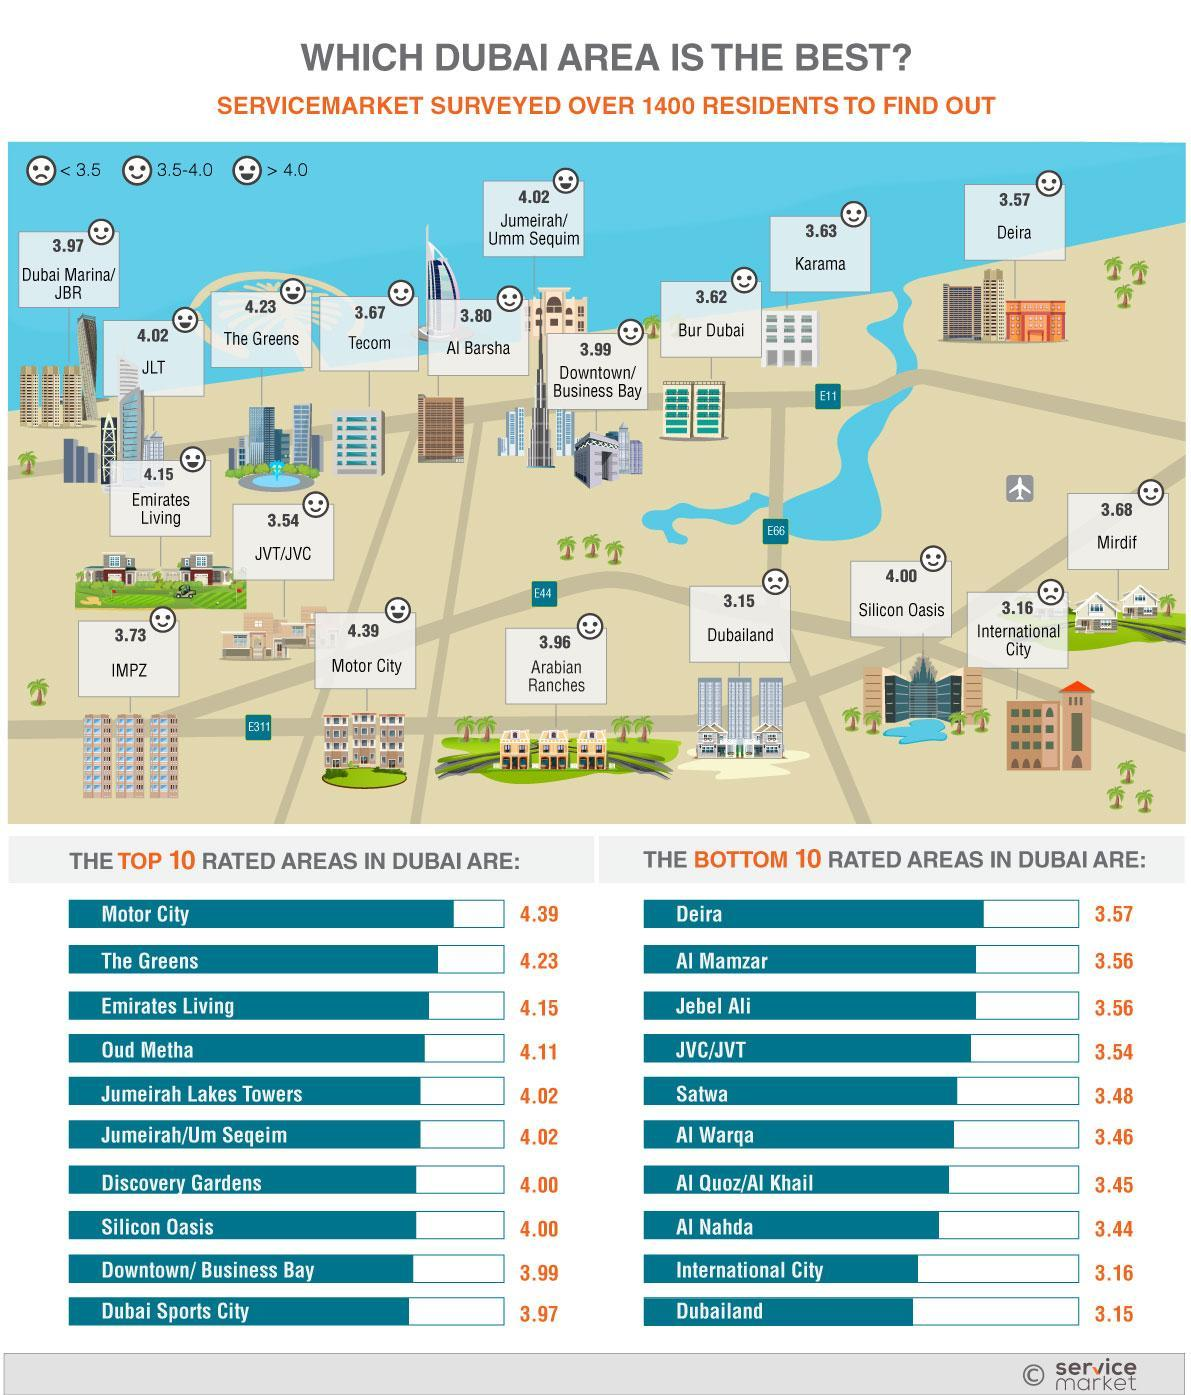Which area in Dubai is rated as 3.97 as per the service market survey over 1400 residents?
Answer the question with a short phrase. Dubai Sports City Which is the second least rated area in Dubai according to the service market survey over 1400 residents? International City Which is the least rated area in Dubai according to the service market survey over 1400 residents? Dubailand Which area in Dubai is rated as 4.15 as per the service market survey over 1400 residents? Emirates Living Which is the second top rated area in Dubai according to the service market survey over 1400 residents? The Greens Which is the top rated area in Dubai according to the service market survey over 1400 residents? Motor City 